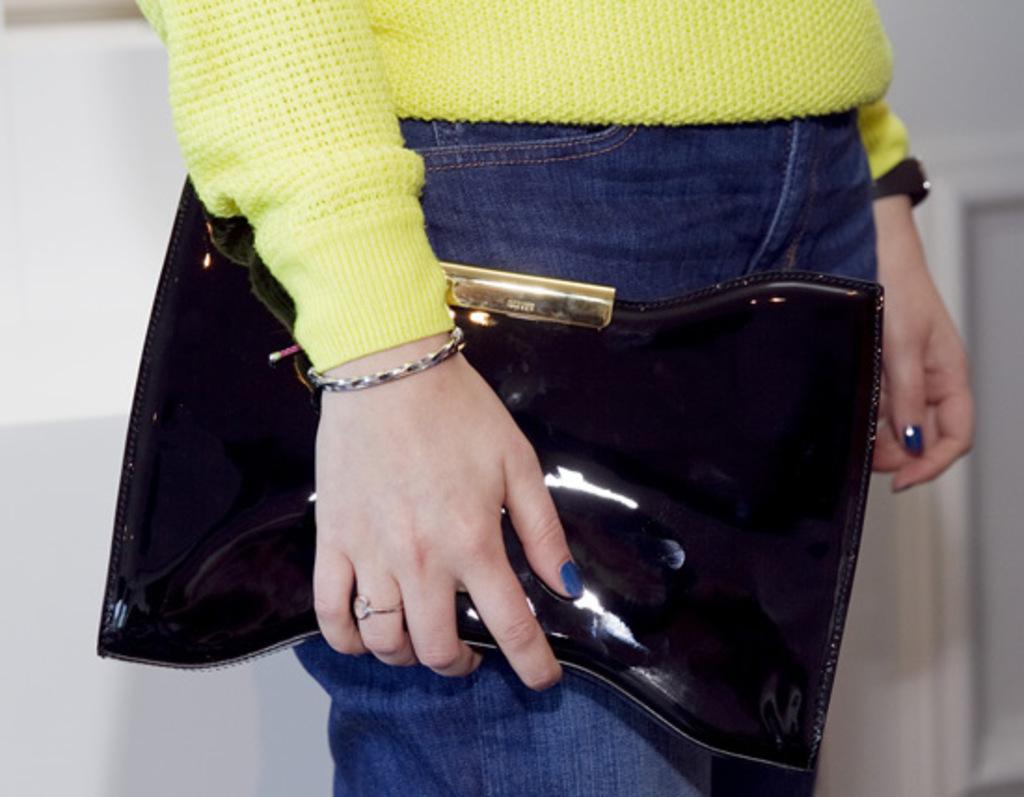Could you give a brief overview of what you see in this image? This image looks like it is clicked inside the room. The woman is wearing yellow shirt and blue jeans. And holding a black color purse in her hand. she is also wearing watch. In the background there is a wall. 